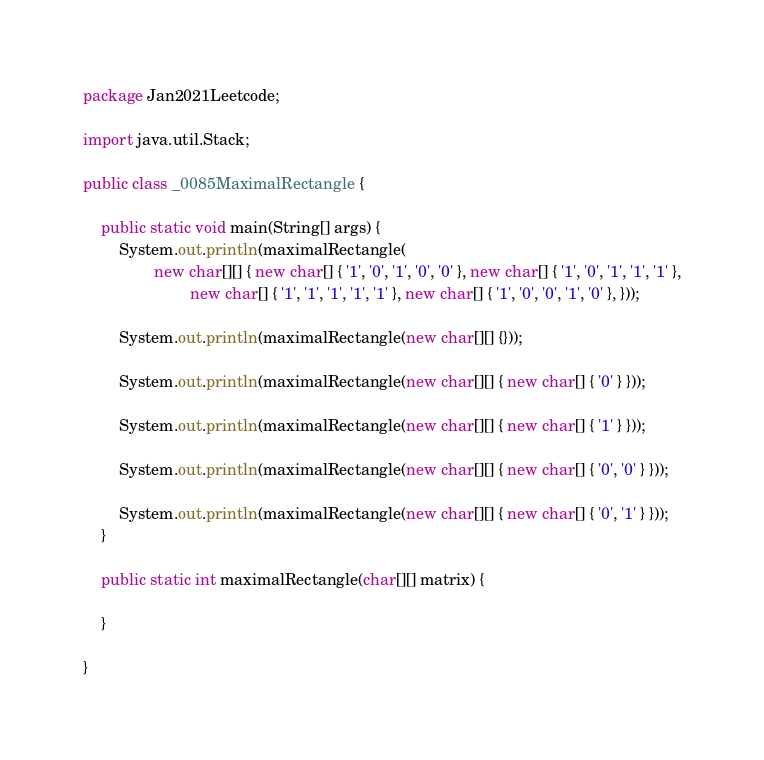<code> <loc_0><loc_0><loc_500><loc_500><_Java_>package Jan2021Leetcode;

import java.util.Stack;

public class _0085MaximalRectangle {

	public static void main(String[] args) {
		System.out.println(maximalRectangle(
				new char[][] { new char[] { '1', '0', '1', '0', '0' }, new char[] { '1', '0', '1', '1', '1' },
						new char[] { '1', '1', '1', '1', '1' }, new char[] { '1', '0', '0', '1', '0' }, }));

		System.out.println(maximalRectangle(new char[][] {}));

		System.out.println(maximalRectangle(new char[][] { new char[] { '0' } }));

		System.out.println(maximalRectangle(new char[][] { new char[] { '1' } }));

		System.out.println(maximalRectangle(new char[][] { new char[] { '0', '0' } }));

		System.out.println(maximalRectangle(new char[][] { new char[] { '0', '1' } }));
	}

	public static int maximalRectangle(char[][] matrix) {
		
	}

}
</code> 